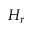Convert formula to latex. <formula><loc_0><loc_0><loc_500><loc_500>H _ { r }</formula> 